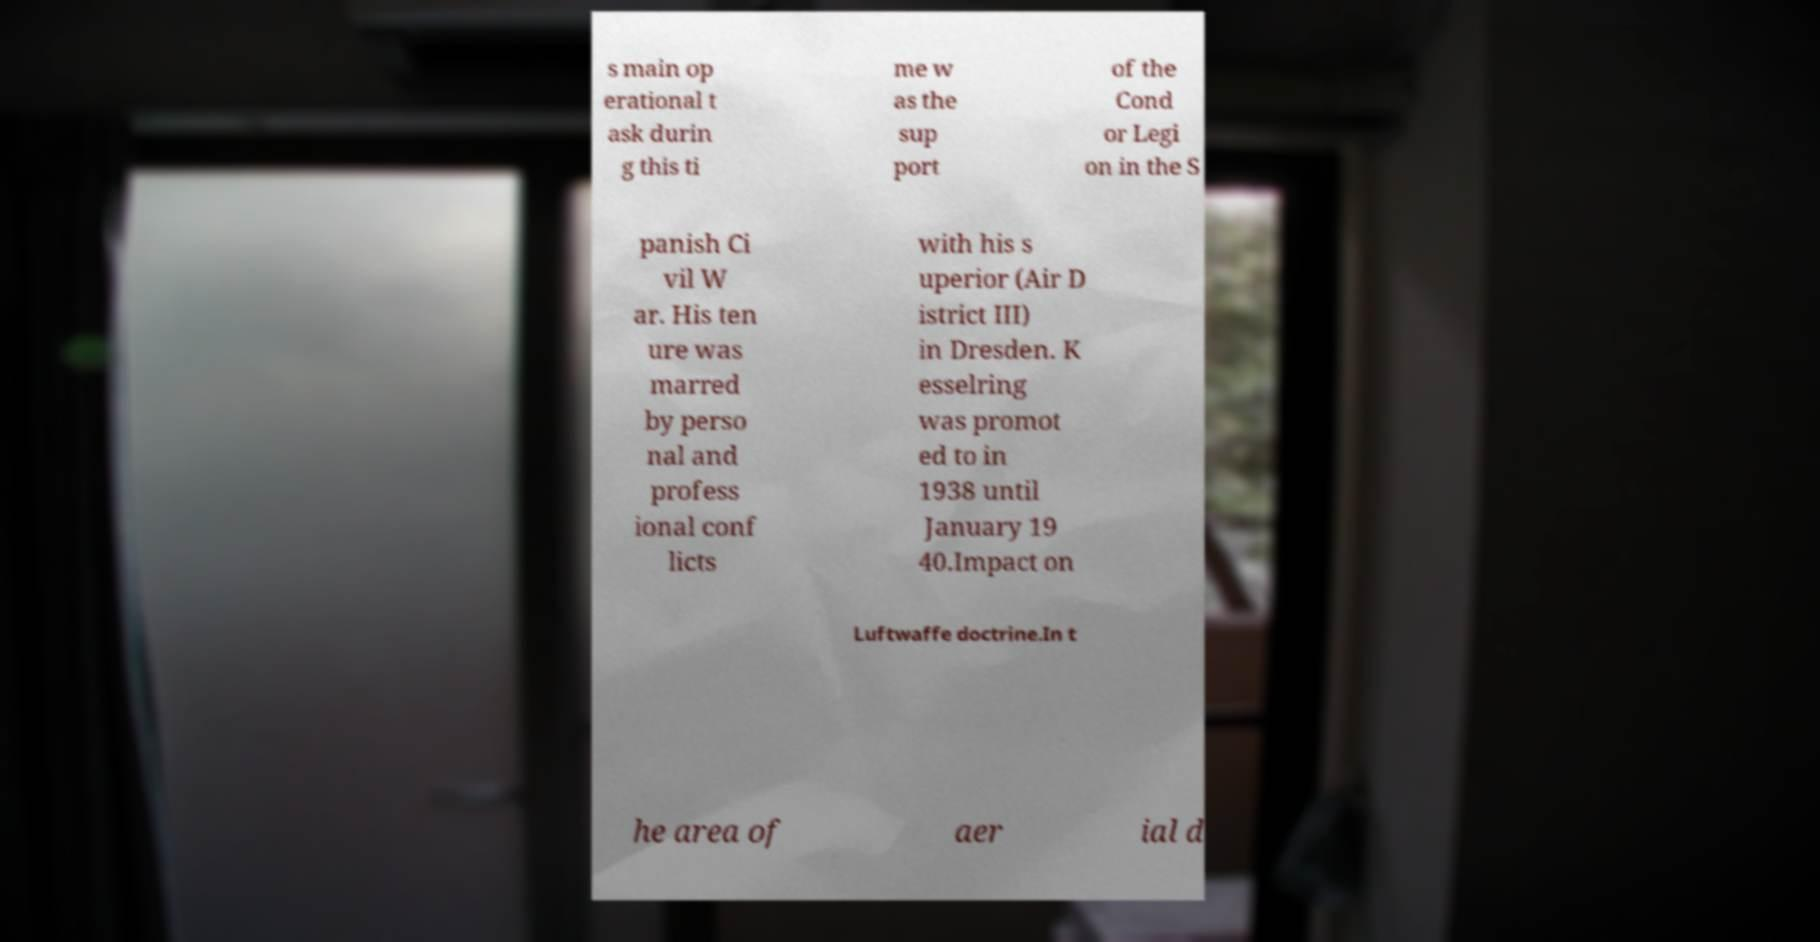Please identify and transcribe the text found in this image. s main op erational t ask durin g this ti me w as the sup port of the Cond or Legi on in the S panish Ci vil W ar. His ten ure was marred by perso nal and profess ional conf licts with his s uperior (Air D istrict III) in Dresden. K esselring was promot ed to in 1938 until January 19 40.Impact on Luftwaffe doctrine.In t he area of aer ial d 